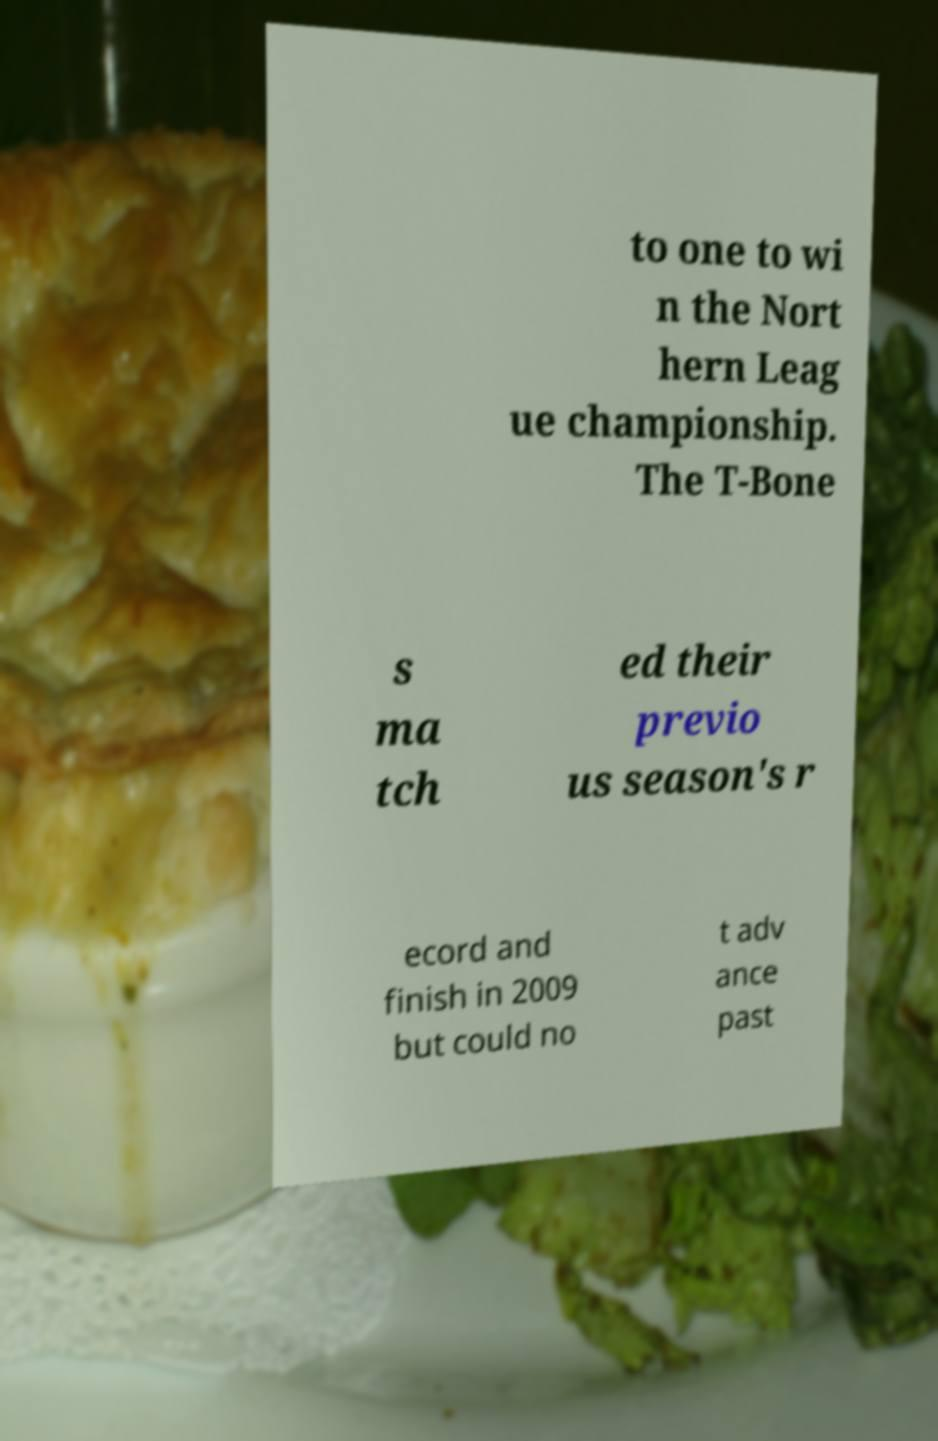Can you read and provide the text displayed in the image?This photo seems to have some interesting text. Can you extract and type it out for me? to one to wi n the Nort hern Leag ue championship. The T-Bone s ma tch ed their previo us season's r ecord and finish in 2009 but could no t adv ance past 